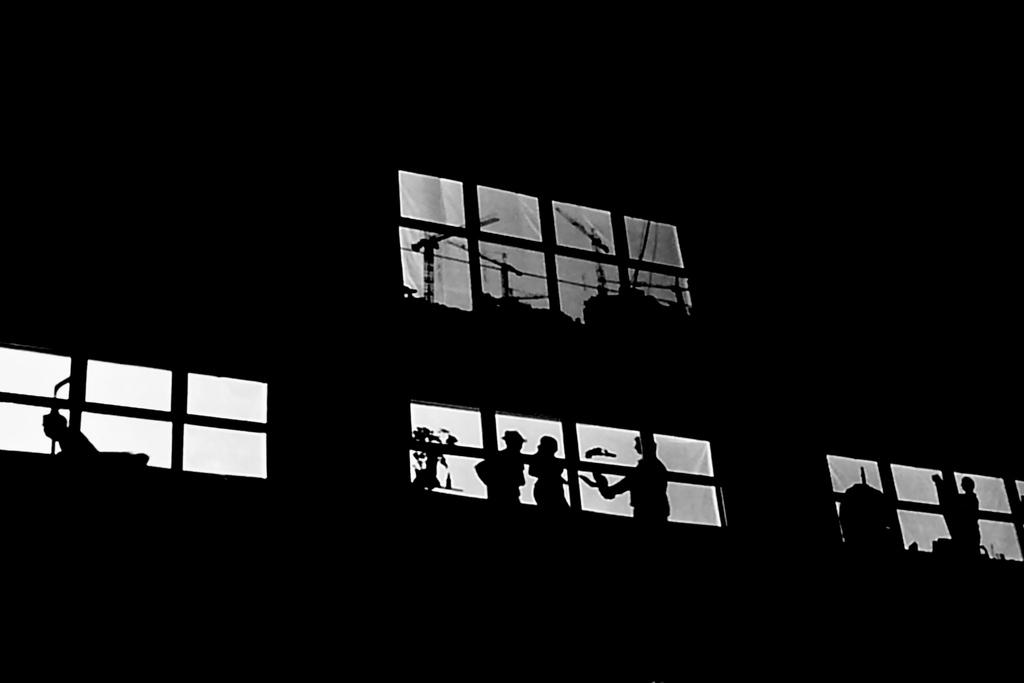What animal is depicted in the painting? The painting contains a crane. Are there any human figures in the painting? Yes, there are people in the painting. Can you describe the attire of one of the people in the painting? One person in the painting is wearing a hat. What color scheme is used in the painting? The painting is in black and white color. Where is the basin located in the painting? There is no basin present in the painting. What type of authority does the person wearing the hat have in the painting? The painting does not provide information about the person's authority; it only shows that they are wearing a hat. 